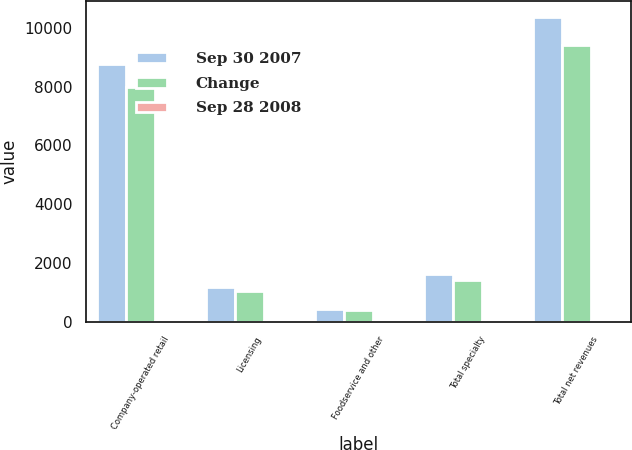Convert chart to OTSL. <chart><loc_0><loc_0><loc_500><loc_500><stacked_bar_chart><ecel><fcel>Company-operated retail<fcel>Licensing<fcel>Foodservice and other<fcel>Total specialty<fcel>Total net revenues<nl><fcel>Sep 30 2007<fcel>8771.9<fcel>1171.6<fcel>439.5<fcel>1611.1<fcel>10383<nl><fcel>Change<fcel>7998.3<fcel>1026.3<fcel>386.9<fcel>1413.2<fcel>9411.5<nl><fcel>Sep 28 2008<fcel>9.7<fcel>14.2<fcel>13.6<fcel>14<fcel>10.3<nl></chart> 